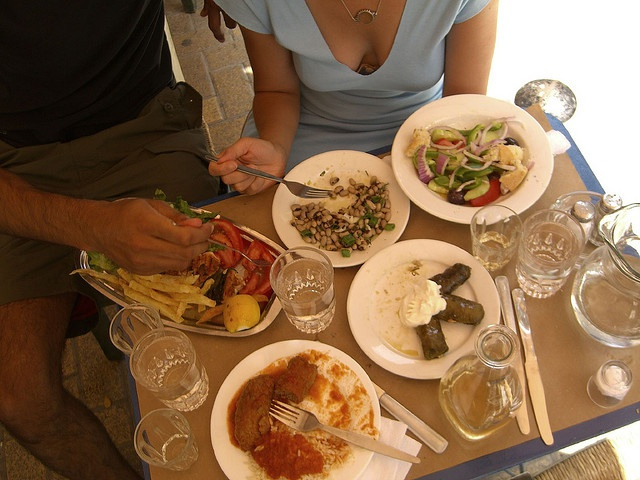Describe the objects in this image and their specific colors. I can see dining table in black, brown, tan, gray, and maroon tones, people in black, maroon, and brown tones, people in black, gray, maroon, and brown tones, bowl in black and tan tones, and cup in black, tan, and gray tones in this image. 